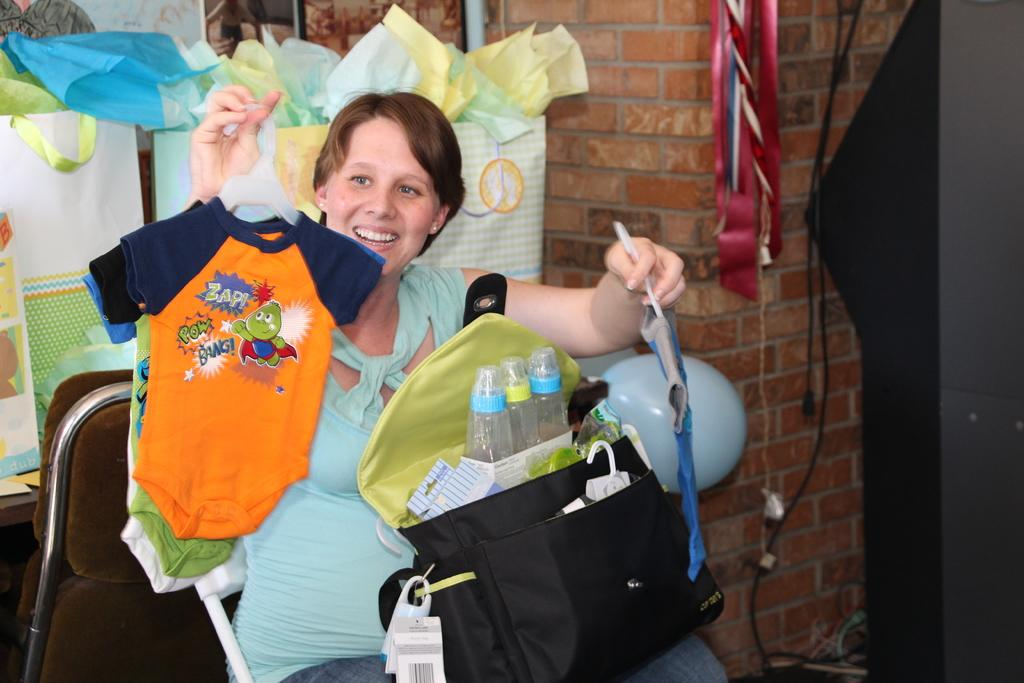Who is the main subject in the image? There is a woman in the image. What is the woman doing in the image? The woman is sitting. What is the woman holding in her hands? The woman is holding clothes in her hands. What is on the woman in the image? There is a bag on the woman. What can be seen in the background of the image? There are bags and a wall in the background of the image. What type of music can be heard playing in the background of the image? There is no music present in the image; it is a still photograph of a woman sitting with clothes and bags. 